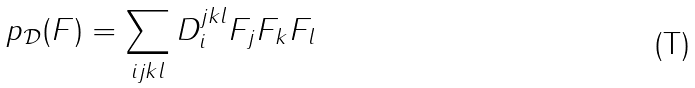Convert formula to latex. <formula><loc_0><loc_0><loc_500><loc_500>p _ { \mathcal { D } } ( F ) = \sum _ { i j k l } D _ { i } ^ { j k l } F _ { j } F _ { k } F _ { l }</formula> 